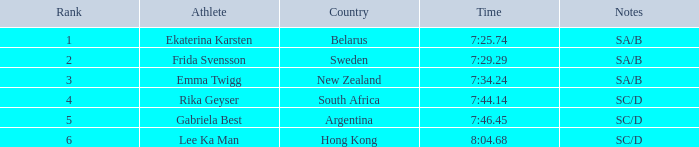What is the competition duration for emma twigg? 7:34.24. 